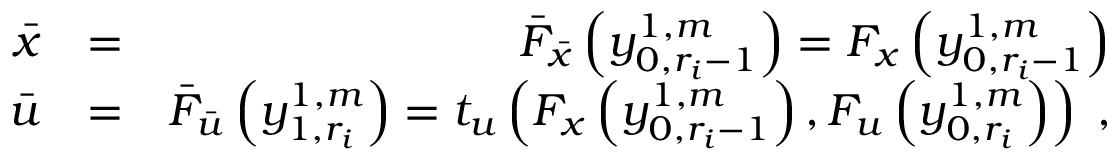Convert formula to latex. <formula><loc_0><loc_0><loc_500><loc_500>\begin{array} { r l r } { \bar { x } } & { = } & { \bar { F } _ { \bar { x } } \left ( y _ { 0 , r _ { i } - 1 } ^ { 1 , m } \right ) = F _ { x } \left ( y _ { 0 , r _ { i } - 1 } ^ { 1 , m } \right ) } \\ { \bar { u } } & { = } & { \bar { F } _ { \bar { u } } \left ( y _ { 1 , r _ { i } } ^ { 1 , m } \right ) = t _ { u } \left ( F _ { x } \left ( y _ { 0 , r _ { i } - 1 } ^ { 1 , m } \right ) , F _ { u } \left ( y _ { 0 , r _ { i } } ^ { 1 , m } \right ) \right ) \, , } \end{array}</formula> 